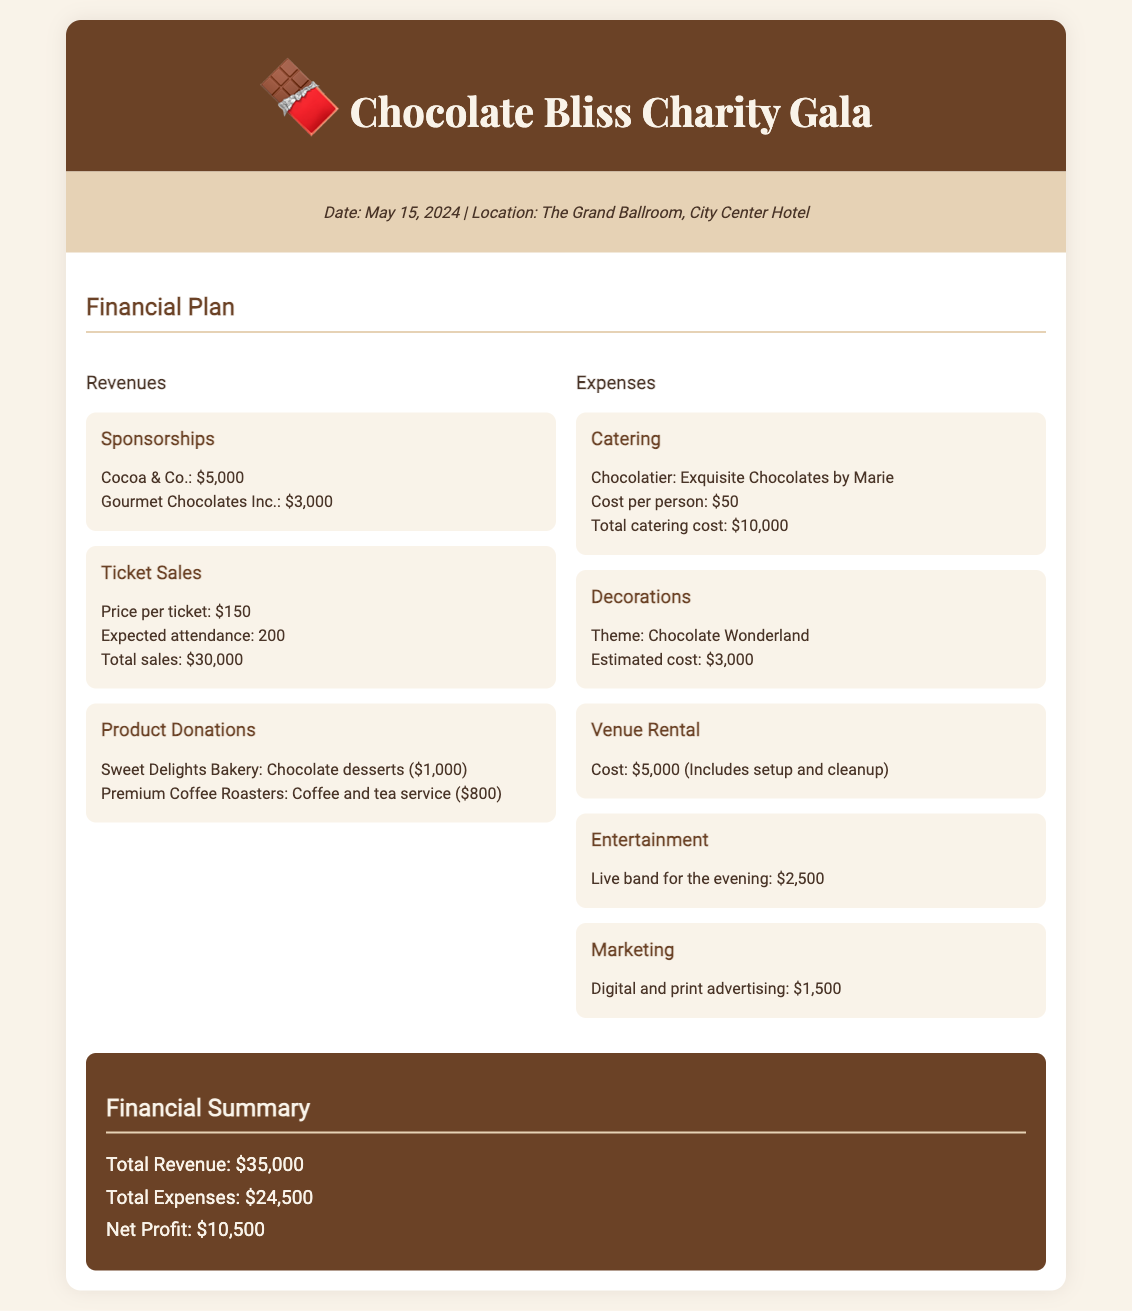What is the date of the event? The date of the event is specified in the document.
Answer: May 15, 2024 Who is the chocolatier mentioned in the catering section? The document includes the name of the chocolatier providing exquisite chocolates.
Answer: Marie What is the total amount of sponsorships? The total sponsorships are calculated by adding the amounts given for each sponsor.
Answer: $8,000 How much does each ticket cost? The document provides the price per ticket for the charity event.
Answer: $150 What is the expected attendance? The document specifies how many attendees are anticipated at the event.
Answer: 200 What is the estimated cost for decorations? The estimated cost for the decorations is specifically mentioned.
Answer: $3,000 What is the total catering cost? The total catering cost can be found in the catering section of the document.
Answer: $10,000 What is the net profit from the event? The net profit is calculated by subtracting total expenses from total revenue.
Answer: $10,500 What is the cost of entertainment for the event? The document outlines the cost for live entertainment during the event.
Answer: $2,500 